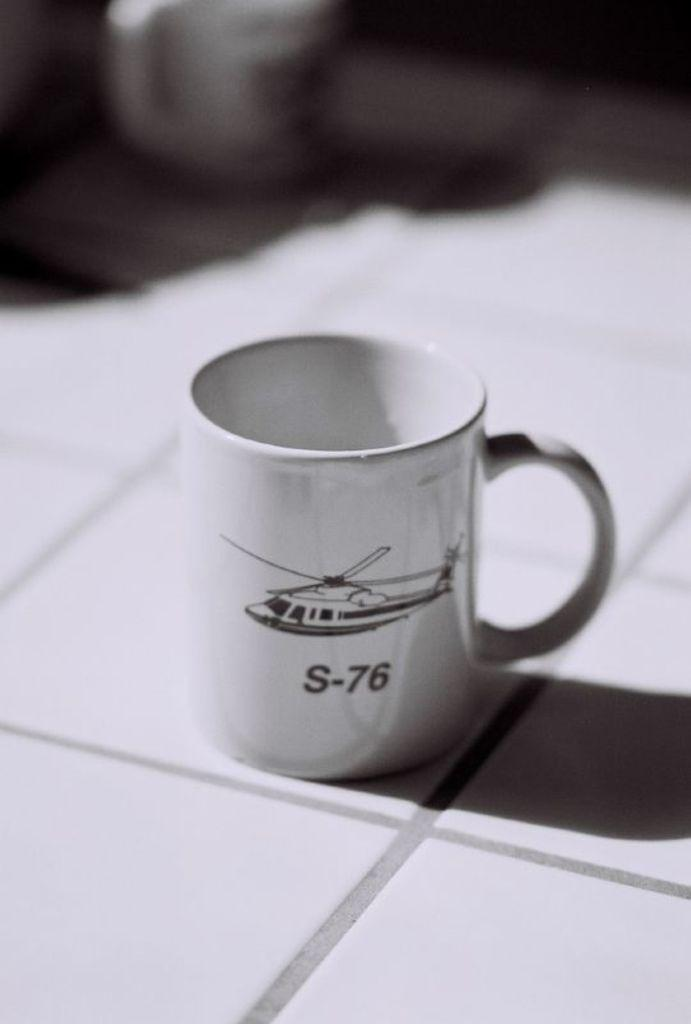<image>
Write a terse but informative summary of the picture. A white coffe mug with an S-76 helicopter on a tile counter top. 